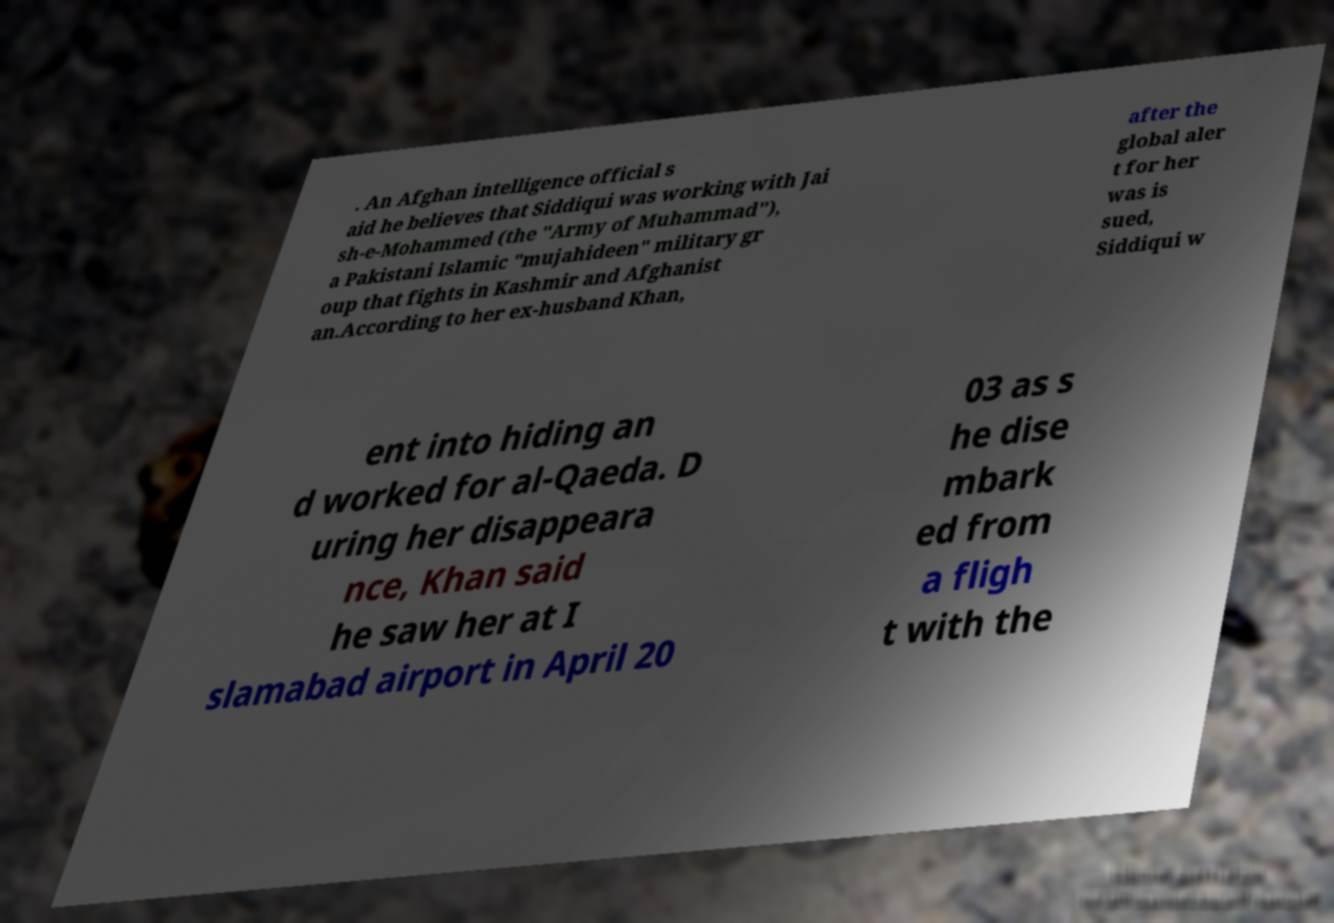Could you extract and type out the text from this image? . An Afghan intelligence official s aid he believes that Siddiqui was working with Jai sh-e-Mohammed (the "Army of Muhammad"), a Pakistani Islamic "mujahideen" military gr oup that fights in Kashmir and Afghanist an.According to her ex-husband Khan, after the global aler t for her was is sued, Siddiqui w ent into hiding an d worked for al-Qaeda. D uring her disappeara nce, Khan said he saw her at I slamabad airport in April 20 03 as s he dise mbark ed from a fligh t with the 